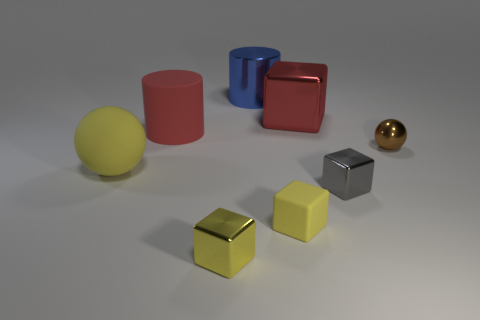Does the matte cylinder have the same color as the big cube?
Give a very brief answer. Yes. Is there a blue metallic cylinder that has the same size as the yellow rubber ball?
Make the answer very short. Yes. Are there more small yellow things that are to the right of the large yellow thing than large yellow spheres?
Provide a succinct answer. Yes. What number of big objects are red cubes or metal objects?
Provide a succinct answer. 2. What number of red rubber things are the same shape as the large blue metal thing?
Your response must be concise. 1. The block that is right of the cube that is behind the tiny brown object is made of what material?
Ensure brevity in your answer.  Metal. How big is the red object that is right of the blue cylinder?
Your answer should be compact. Large. What number of gray things are matte blocks or tiny balls?
Your answer should be compact. 0. What is the material of the other big object that is the same shape as the big red rubber thing?
Ensure brevity in your answer.  Metal. Is the number of small metal balls left of the rubber cube the same as the number of big green shiny objects?
Provide a short and direct response. Yes. 